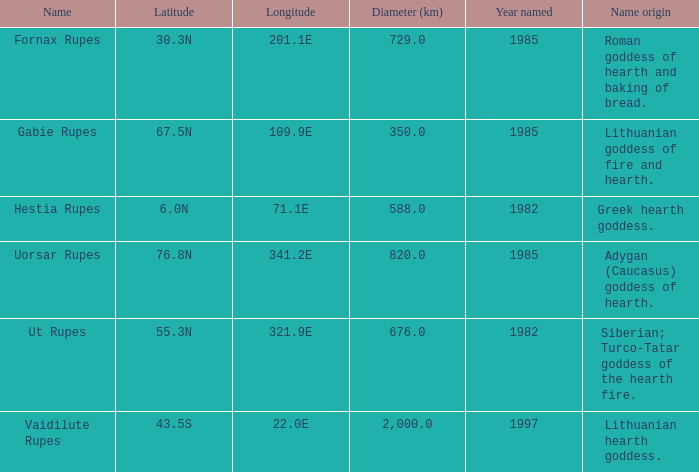9e longitude, what is the latitude of the identified features? 55.3N. 